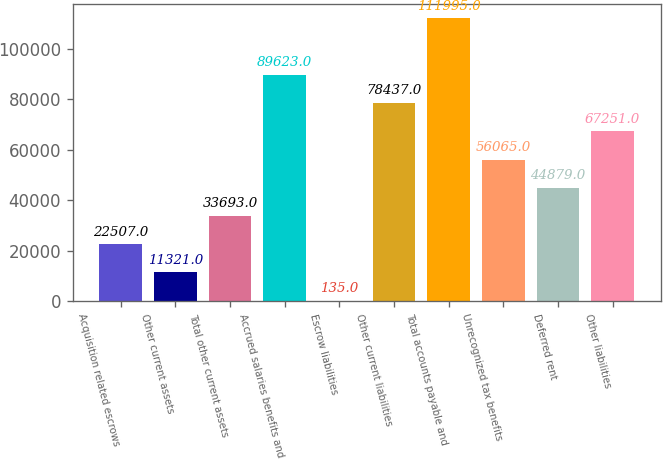<chart> <loc_0><loc_0><loc_500><loc_500><bar_chart><fcel>Acquisition related escrows<fcel>Other current assets<fcel>Total other current assets<fcel>Accrued salaries benefits and<fcel>Escrow liabilities<fcel>Other current liabilities<fcel>Total accounts payable and<fcel>Unrecognized tax benefits<fcel>Deferred rent<fcel>Other liabilities<nl><fcel>22507<fcel>11321<fcel>33693<fcel>89623<fcel>135<fcel>78437<fcel>111995<fcel>56065<fcel>44879<fcel>67251<nl></chart> 